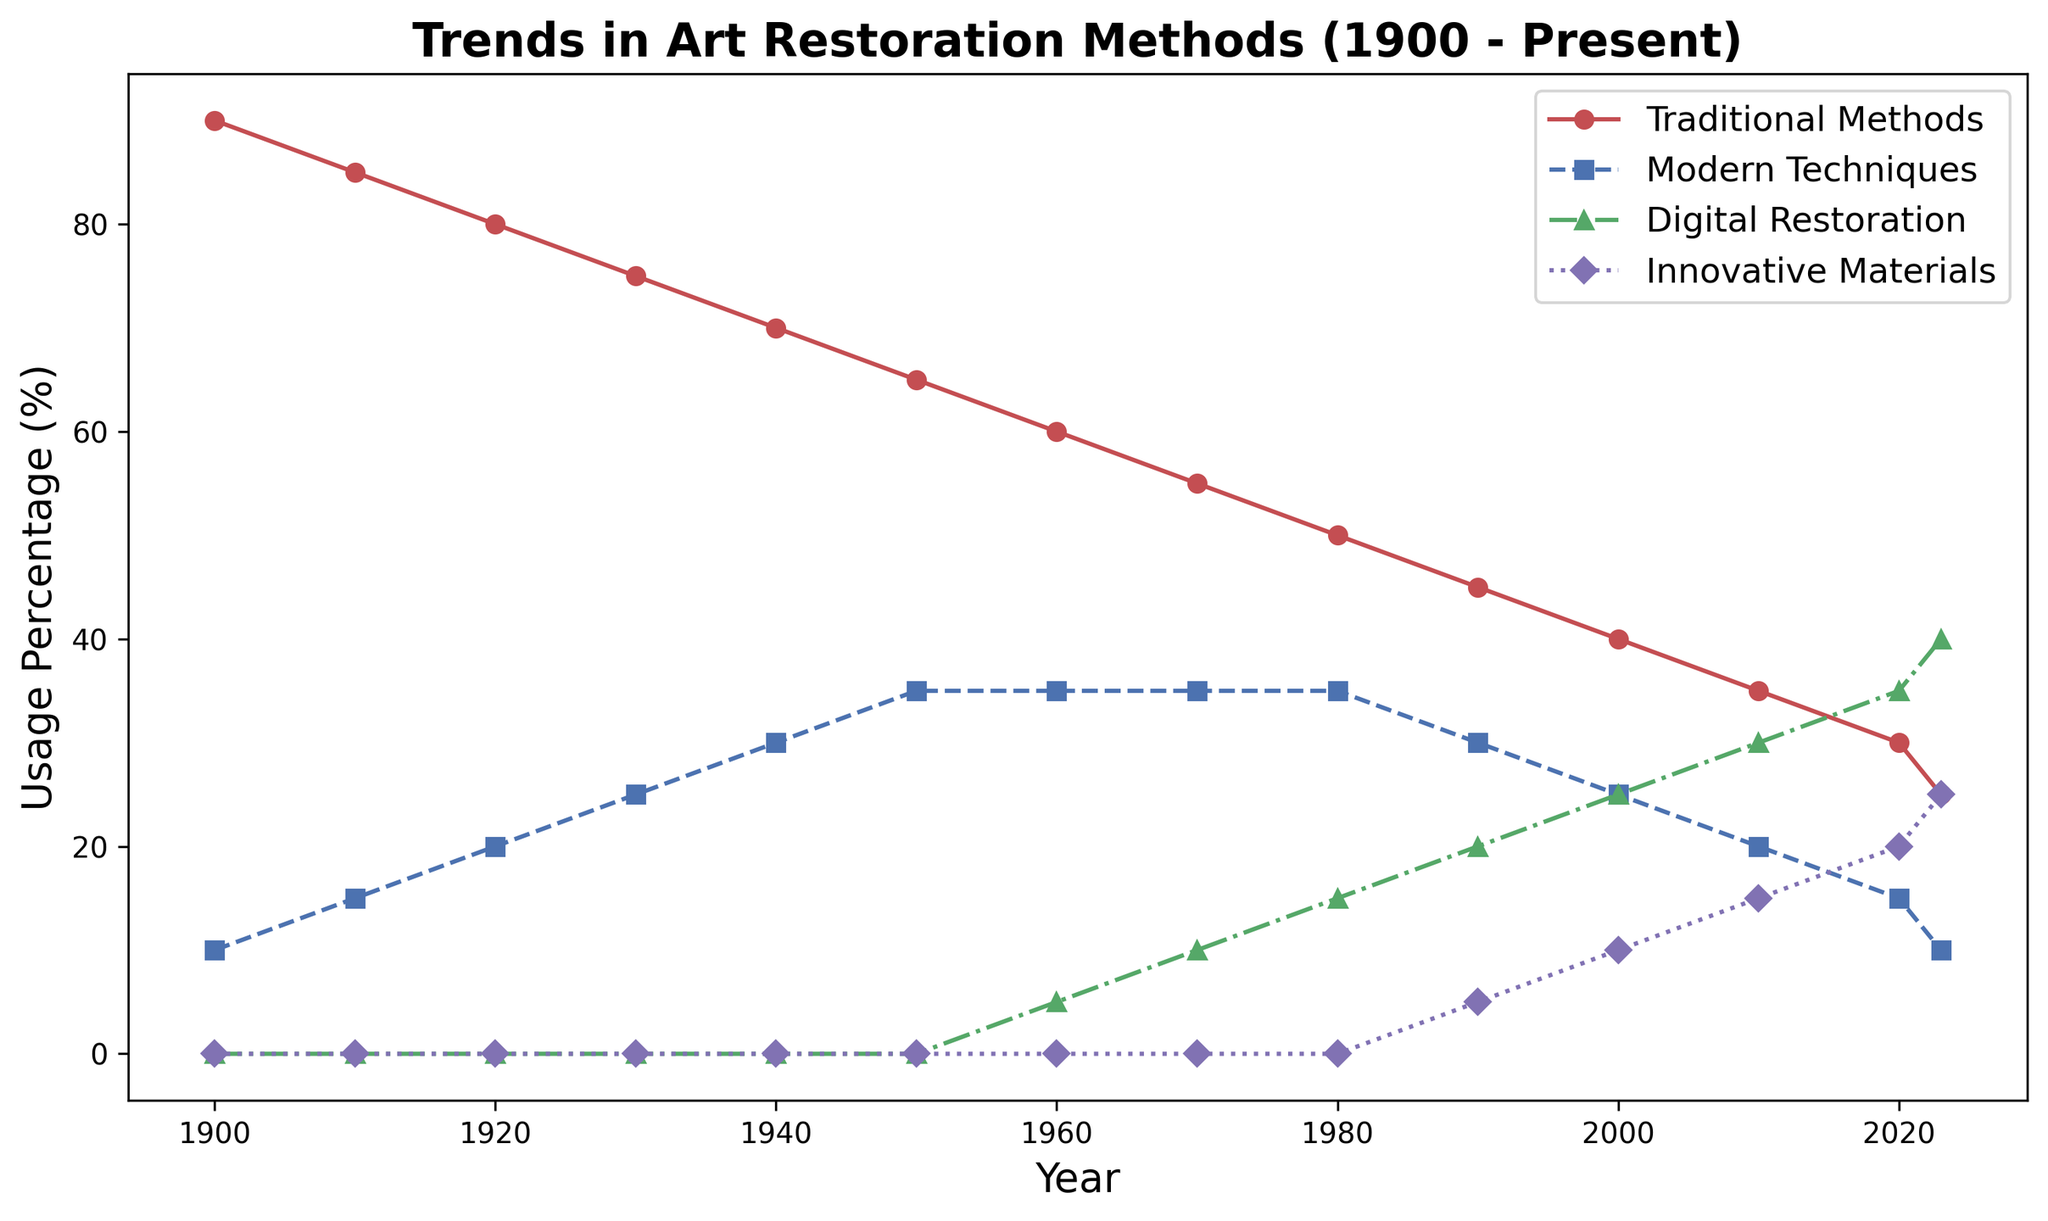What trend is shown for Traditional Methods from 1900 to 2023? Traditional Methods show a consistent decrease in usage over the entire timeline. This can be seen as the usage percentage drops steadily from 90% in 1900 to 25% in 2023.
Answer: A consistent decrease Which year shows the highest percentage of Modern Techniques? By looking at the plot for Modern Techniques (blue line), the highest percentage is seen in 1950 at 35%.
Answer: 1950 When do Digital Restoration methods first appear in the data? Digital Restoration (green line) is first plotted in 1960, indicating when it appears in the data.
Answer: 1960 Compare the usage percentages of Innovative Materials in 1990 and 2023. Which year has higher usage? Innovative Materials in 1990 are at 5%, while in 2023, it has increased to 25%. Clearly, 2023 has higher usage compared to 1990.
Answer: 2023 What is the sum of the percentages of Digital Restoration and Innovative Materials in 2023? From the plot, Digital Restoration in 2023 is at 40% and Innovative Materials at 25%. Adding these gives 40% + 25% = 65%.
Answer: 65% Which restoration method had the most stable trend (least change in percentage) over the years? By comparing the trends, Modern Techniques (blue line) show relatively stable usage with minor fluctuations, unlike the other methods which show more significant changes.
Answer: Modern Techniques What is the difference in usage percentage between Traditional Methods and Digital Restoration in 2023? From the figure in 2023, Traditional Methods are at 25% and Digital Restoration is at 40%. The difference is 40% - 25% = 15%.
Answer: 15% In which decades did Traditional Methods see the sharpest decline? The sharpest decline is seen between 1900 and 1960, where each decade shows a consistent drop of 5%. This is a noticeable and sharp decrease compared to other periods.
Answer: 1900-1960 Compare the intersection years of Traditional Methods and Digital Restoration. Identify the decade in which they intersect or come closest. Traditional Methods (red line) and Digital Restoration (green line) come closest around the 2000s. By 2023, Digital Restoration overtakes Traditional Methods.
Answer: 2000s What is the average percentage usage of Modern Techniques between 1900 and 2023? The data points for Modern Techniques are: 10, 15, 20, 25, 30, 35, 35, 35, 35, 30, 25, 20, 15, 10. Adding these gives 335, and there are 14 points; hence the average is 335 / 14 ≈ 23.93.
Answer: 23.93% 